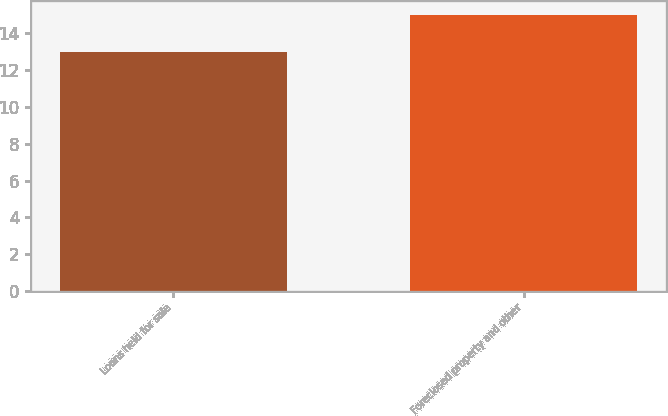Convert chart to OTSL. <chart><loc_0><loc_0><loc_500><loc_500><bar_chart><fcel>Loans held for sale<fcel>Foreclosed property and other<nl><fcel>13<fcel>15<nl></chart> 